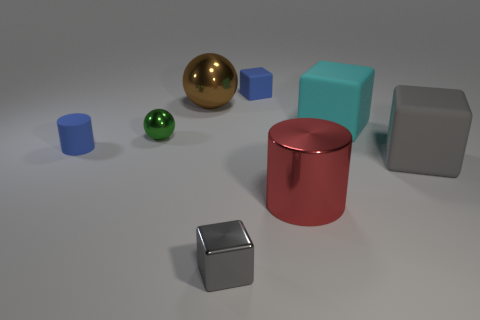The small rubber object that is the same color as the tiny matte cube is what shape?
Provide a succinct answer. Cylinder. Are there the same number of gray metal things that are behind the tiny blue cube and cyan cubes?
Ensure brevity in your answer.  No. There is a gray object that is left of the tiny matte cube; what is its size?
Give a very brief answer. Small. What number of tiny objects are gray shiny cylinders or red objects?
Provide a short and direct response. 0. What color is the tiny rubber thing that is the same shape as the large cyan matte object?
Offer a terse response. Blue. Do the brown metal thing and the matte cylinder have the same size?
Give a very brief answer. No. What number of objects are either rubber objects or big blocks in front of the green ball?
Offer a very short reply. 4. What is the color of the tiny thing that is right of the gray thing that is left of the gray rubber block?
Ensure brevity in your answer.  Blue. There is a tiny cube that is behind the small green metallic object; does it have the same color as the small matte cylinder?
Your answer should be compact. Yes. What is the material of the gray thing that is to the left of the large cylinder?
Provide a short and direct response. Metal. 